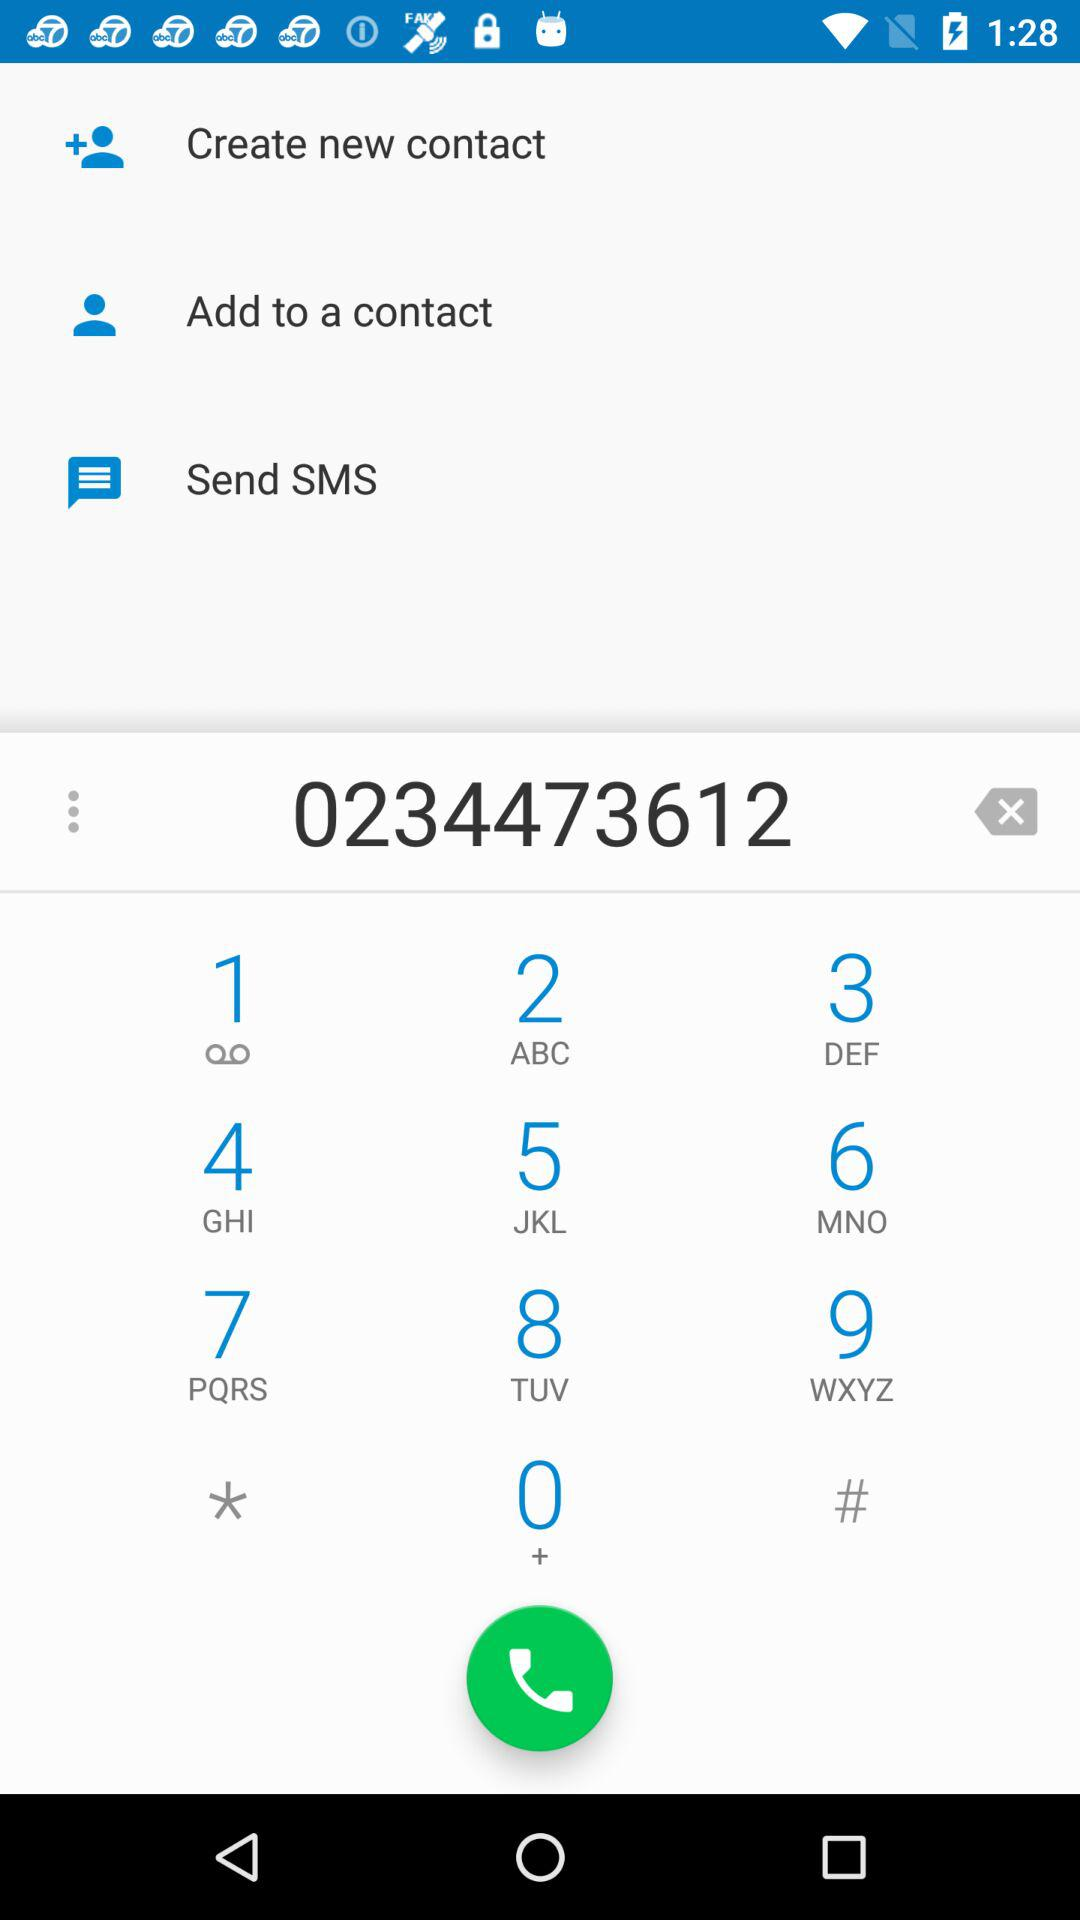What is the given phone number? The given phone number is 0234473612. 